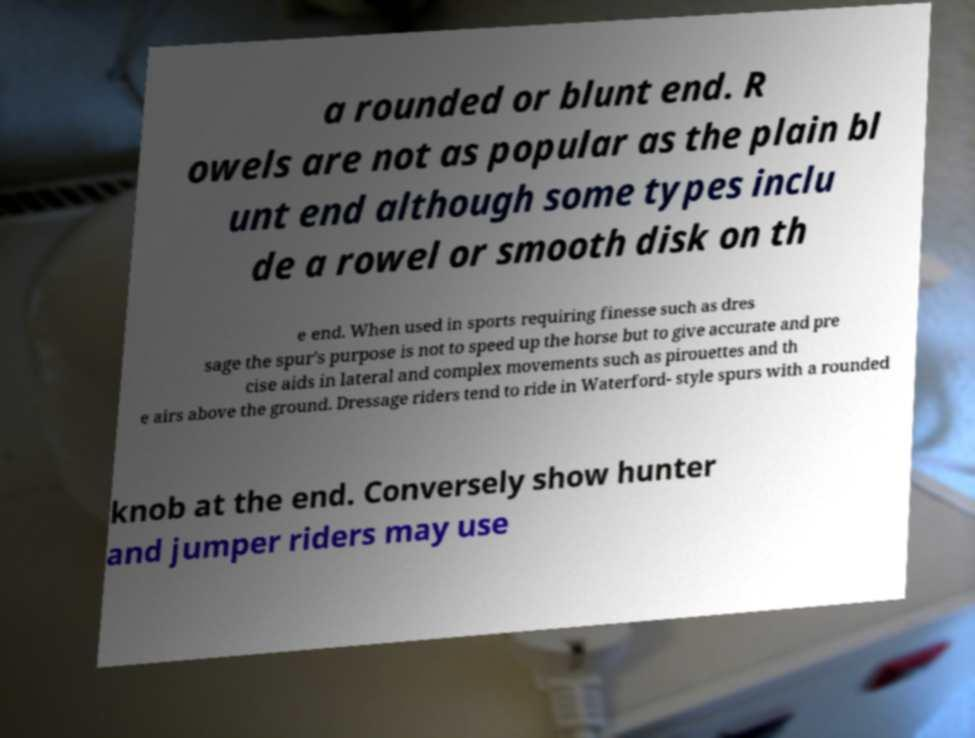Could you assist in decoding the text presented in this image and type it out clearly? a rounded or blunt end. R owels are not as popular as the plain bl unt end although some types inclu de a rowel or smooth disk on th e end. When used in sports requiring finesse such as dres sage the spur's purpose is not to speed up the horse but to give accurate and pre cise aids in lateral and complex movements such as pirouettes and th e airs above the ground. Dressage riders tend to ride in Waterford- style spurs with a rounded knob at the end. Conversely show hunter and jumper riders may use 